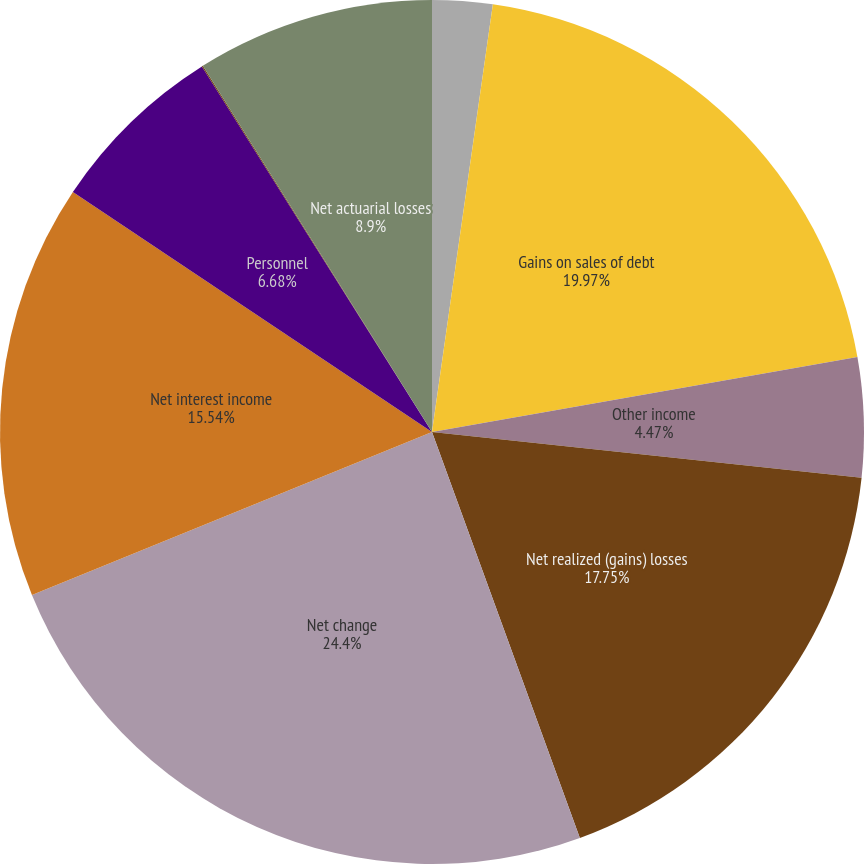Convert chart. <chart><loc_0><loc_0><loc_500><loc_500><pie_chart><fcel>Net increase (decrease) in<fcel>Gains on sales of debt<fcel>Other income<fcel>Net realized (gains) losses<fcel>Net change<fcel>Net interest income<fcel>Personnel<fcel>Prior service cost<fcel>Net actuarial losses<nl><fcel>2.25%<fcel>19.97%<fcel>4.47%<fcel>17.75%<fcel>24.4%<fcel>15.54%<fcel>6.68%<fcel>0.04%<fcel>8.9%<nl></chart> 